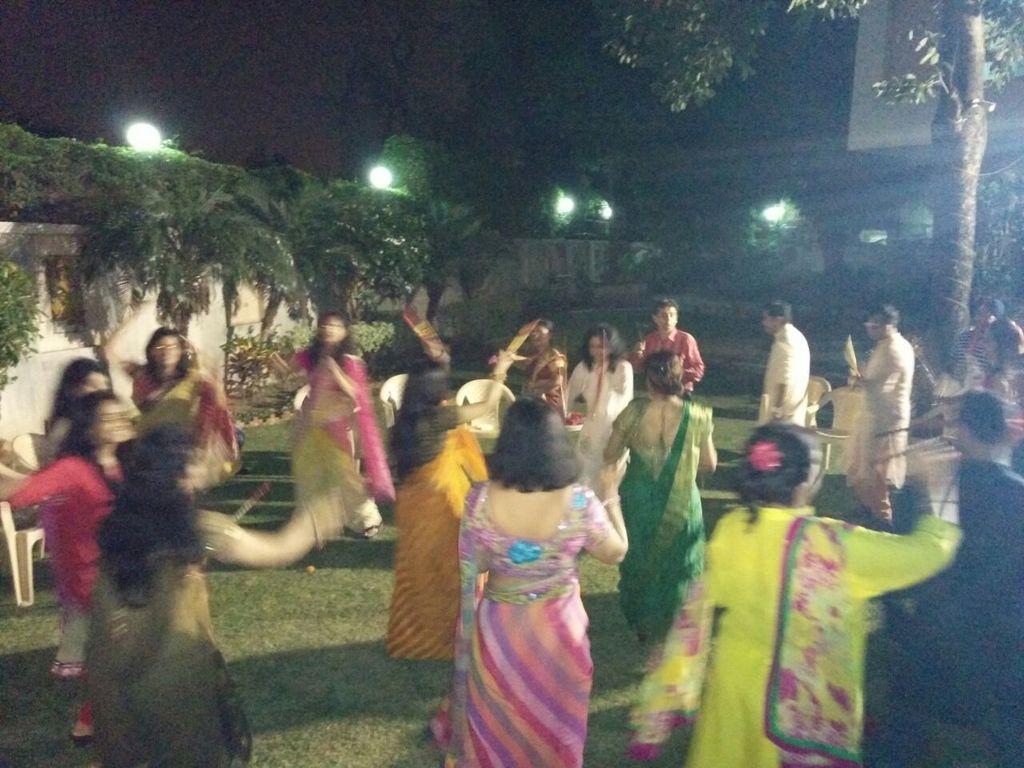Please provide a concise description of this image. In this image I can see group of people dancing. In front the person is wearing multi color saree, background I can see trees and plants in green color and I can see few lights. 